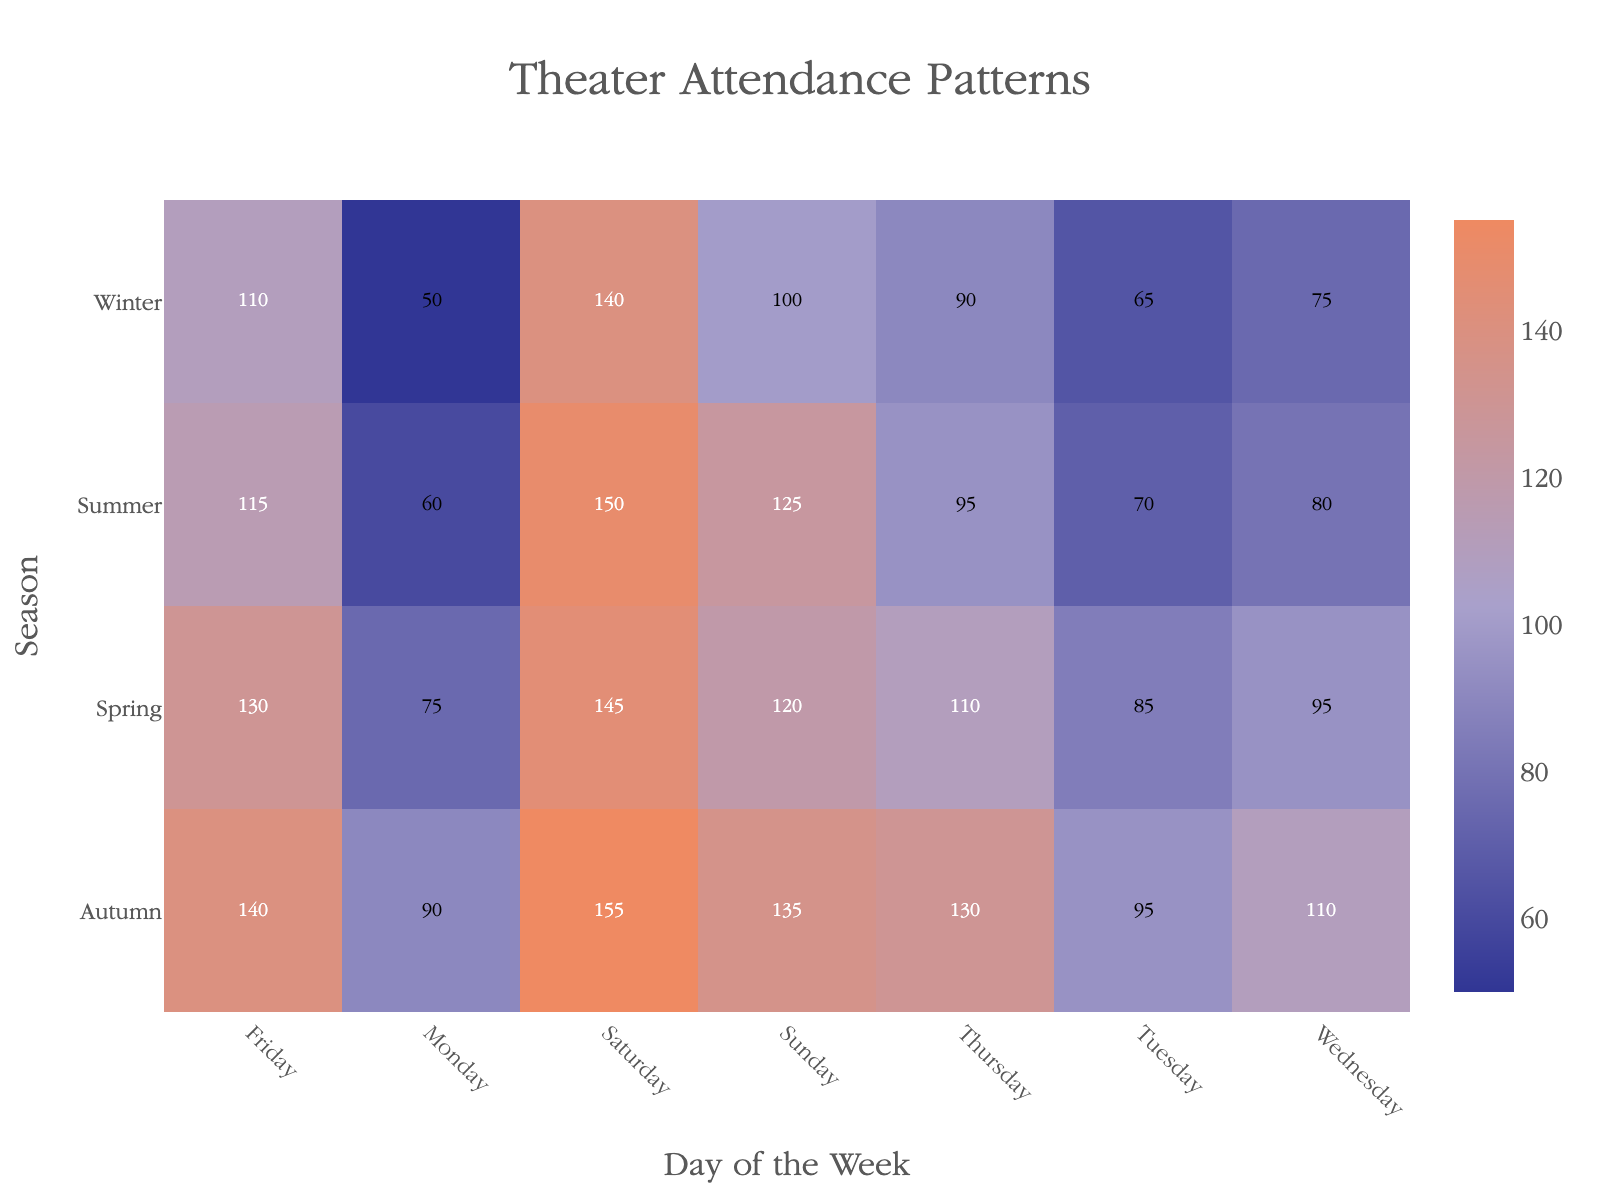How does the attendance on Monday in Winter compare to Monday in Autumn? To determine this, find and compare the attendance values for Monday in Winter and Autumn from the heatmap. Winter Monday shows 50, while Autumn Monday shows 90.
Answer: Winter Monday has lower attendance Which day of the week has the highest attendance in Summer? Check the Summer row and identify the highest value. Saturday has the value 150, which is the highest in that row.
Answer: Saturday What is the sum of attendance figures for all the Thursdays across different seasons? Add the attendance figures for Thursdays across Spring, Summer, Autumn, and Winter. The values are 110 (Spring) + 95 (Summer) + 130 (Autumn) + 90 (Winter). The total is 425.
Answer: 425 Which season has the most consistent attendance throughout the week? Review the attendance values across each day of the week for all seasons. The season with the smallest range between the highest and lowest attendance suggests the most consistency. Autumn ranges from 90 to 155, Summer from 60 to 150, Spring from 75 to 145, Winter from 50 to 140. Autumn has the smallest range (65), suggesting it is the most consistent.
Answer: Autumn What is the average attendance for Saturdays across all seasons? Sum the values of Saturdays for all seasons and divide by the number of seasons. Values are 145 (Spring), 150 (Summer), 155 (Autumn), 140 (Winter). The sum is 590. There are 4 seasons, so the average is 590/4 = 147.5.
Answer: 147.5 Between Spring and Winter, which season has higher overall attendance? Add attendance values for each day of the week for both Spring and Winter. Spring: 75 + 85 + 95 + 110 + 130 + 145 + 120 = 760. Winter: 50 + 65 + 75 + 90 + 110 + 140 + 100 = 630. Compare the totals. Spring has higher attendance.
Answer: Spring What is the difference between the highest and lowest attendance values in the whole dataset? Identify the highest value (155) and the lowest value (50) from the heatmap and calculate the difference. The difference is 155 - 50 = 105.
Answer: 105 On which day is the difference between the highest recorded attendance and lowest recorded attendance the largest? Calculate the range (highest value - lowest value) for each day of the week across all seasons. Monday (90 - 50 = 40), Tuesday (95 - 65 = 30), Wednesday (110 - 75 = 35), Thursday (130 - 90 = 40), Friday (140 - 110 = 30), Saturday (155 - 140 = 15), Sunday (135 - 100 = 35). Compare to find the largest difference, which happens on Monday and Thursday (both 40).
Answer: Monday or Thursday 